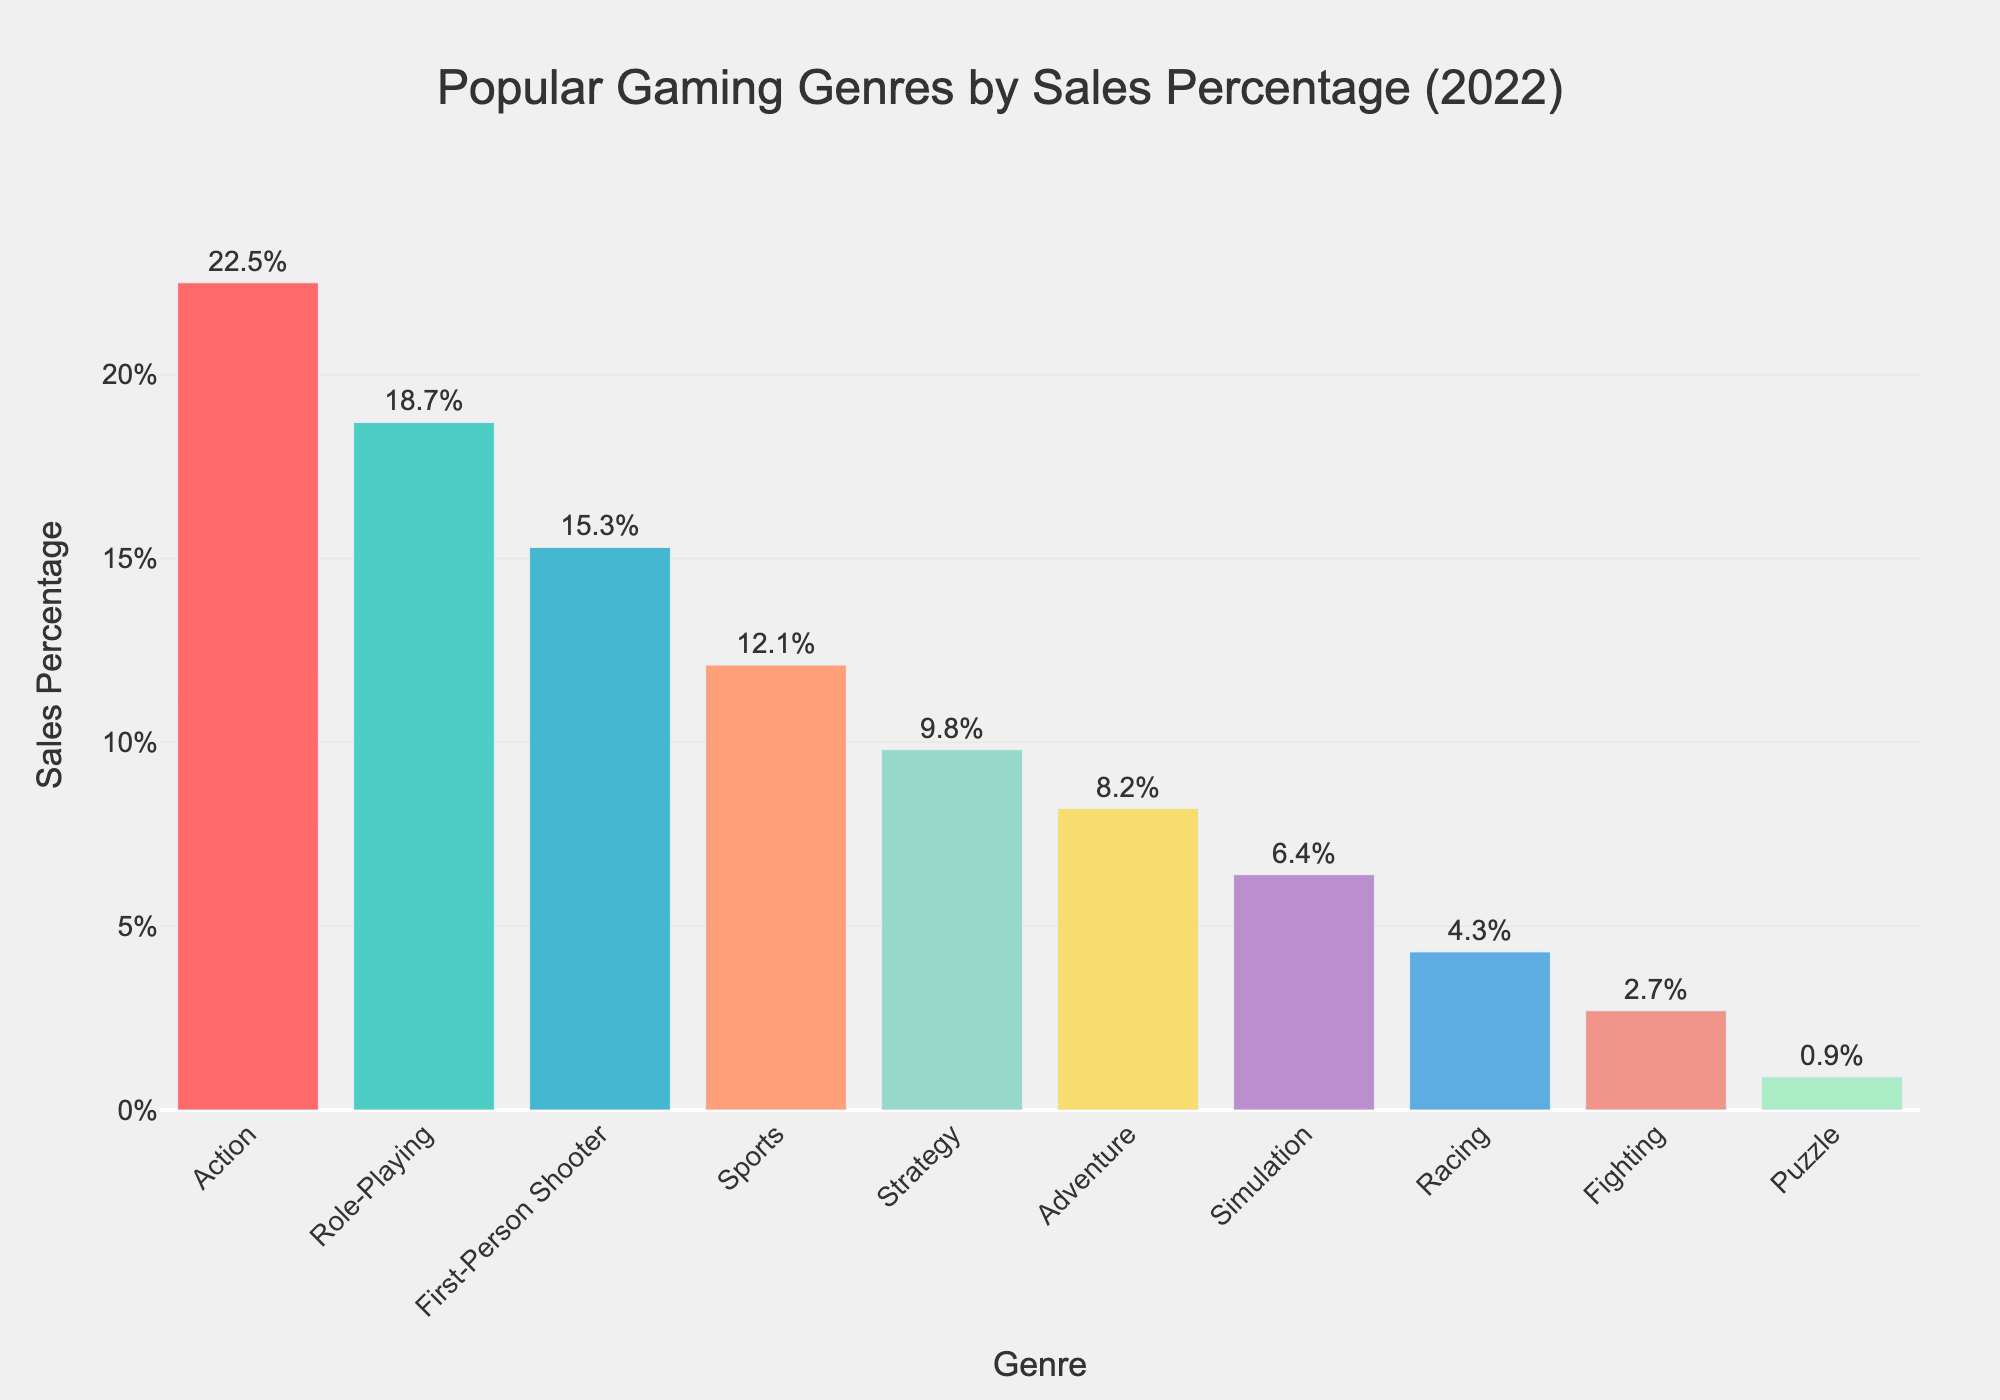What is the most popular gaming genre by sales percentage in 2022? The bar chart shows various gaming genres with their corresponding sales percentages. The tallest bar represents the most popular genre. Here, the tallest bar is for Action, which has the highest sales percentage.
Answer: Action Which genre has the smallest sales percentage? To find the genre with the smallest sales percentage, look for the shortest bar in the chart. The shortest bar represents Puzzle, which shows a 0.9% sales percentage.
Answer: Puzzle How much higher is the sales percentage of Action compared to Puzzle? To determine the difference, find the sales percentages of Action and Puzzle. Action is at 22.5% and Puzzle is at 0.9%. The difference is 22.5% - 0.9% = 21.6%.
Answer: 21.6% What is the combined sales percentage of Role-Playing and Strategy genres? Role-Playing has a sales percentage of 18.7% and Strategy has 9.8%. Adding these together, 18.7% + 9.8% = 28.5%.
Answer: 28.5% Which genre has a higher sales percentage: Sports or Adventure? To decide which genre has a higher sales percentage, compare the heights of the bars for Sports and Adventure. The Sports genre has a higher sales percentage at 12.1%, compared to Adventure at 8.2%.
Answer: Sports What is the average sales percentage of the top three genres? The top three genres by sales percentage are Action (22.5%), Role-Playing (18.7%), and First-Person Shooter (15.3%). The average is calculated as (22.5% + 18.7% + 15.3%)/3 = 56.5/3 = 18.83%.
Answer: 18.83% Which color is used for the bar representing the Racing genre? Finding the color for the Racing genre involves matching the genre name to its color-coded bar in the chart. The Racing genre, represented by a bar with a sales percentage of 4.3%, is shown in light blue.
Answer: light blue Compare the sales percentage of Role-Playing to Simulation. To compare these genres, note that Role-Playing has a sales percentage of 18.7% and Simulation has 6.4%. Role-Playing has a higher sales percentage than Simulation.
Answer: Role-Playing What percentage of sales do genres with a sales percentage less than 5% contribute collectively? Identify the genres with sales percentages less than 5%: Racing (4.3%), Fighting (2.7%), and Puzzle (0.9%). Add these percentages together: 4.3% + 2.7% + 0.9% = 7.9%.
Answer: 7.9% How much lower is the sales percentage of Adventure compared to the average sales percentage of the top three genres? First, calculate the average sales percentage of the top three genres, which is 18.83%. The sales percentage of Adventure is 8.2%. The difference is 18.83% - 8.2% = 10.63%.
Answer: 10.63% 